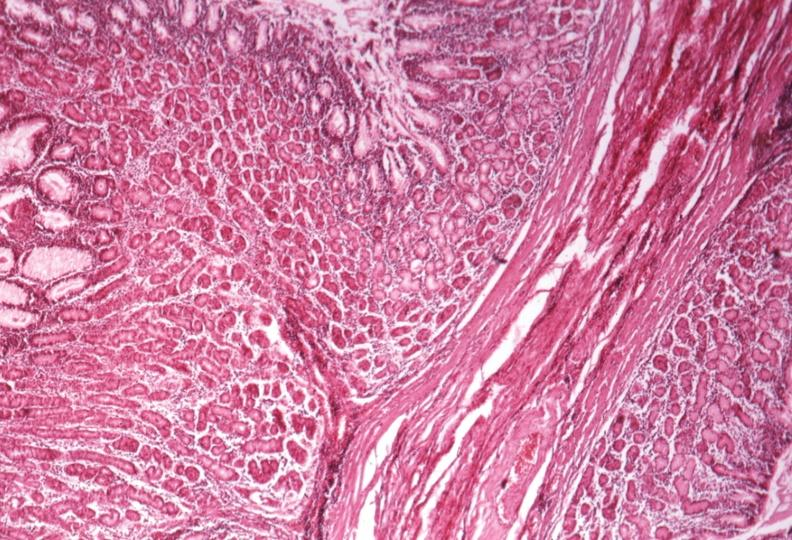s stomach present?
Answer the question using a single word or phrase. Yes 